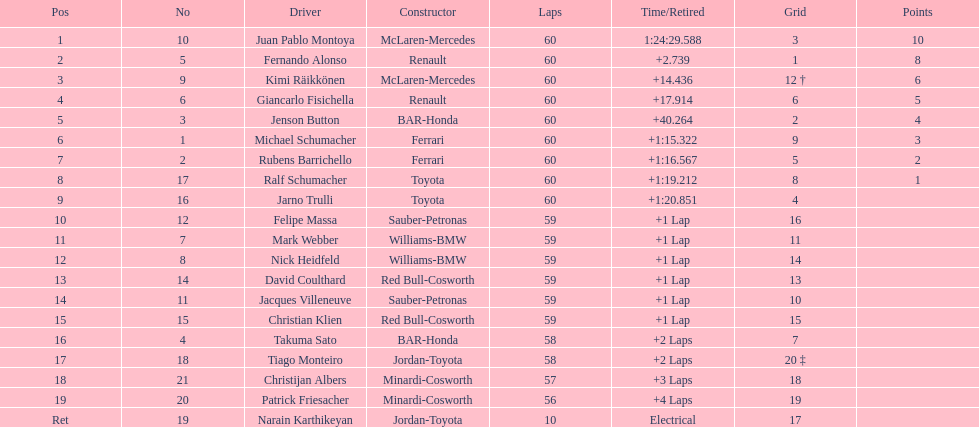Does the point difference exist between the rankings of 9th and 19th on the list? No. 